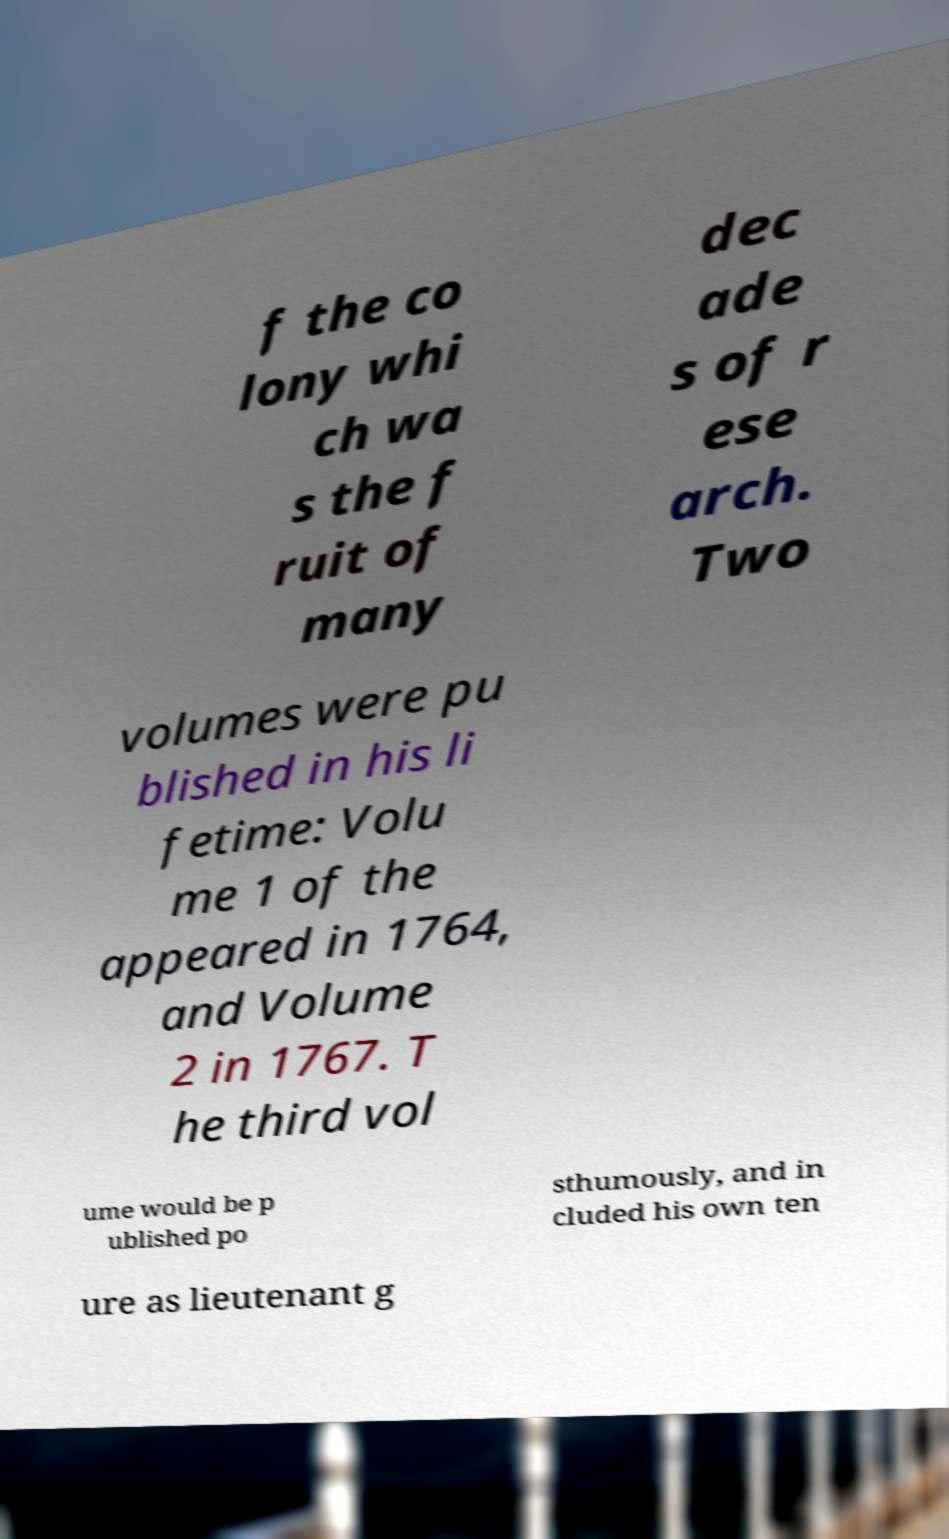Can you read and provide the text displayed in the image?This photo seems to have some interesting text. Can you extract and type it out for me? f the co lony whi ch wa s the f ruit of many dec ade s of r ese arch. Two volumes were pu blished in his li fetime: Volu me 1 of the appeared in 1764, and Volume 2 in 1767. T he third vol ume would be p ublished po sthumously, and in cluded his own ten ure as lieutenant g 